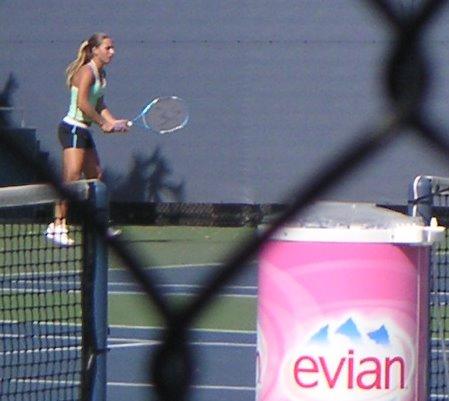What sport is this?
Be succinct. Tennis. What name brand bottled water does this facility provide?
Write a very short answer. Evian. What word are seen in the image?
Short answer required. Evian. What is the girl on the left wearing?
Keep it brief. Shorts. What sport is the girl playing?
Answer briefly. Tennis. Is the player wearing a shorts?
Short answer required. Yes. 